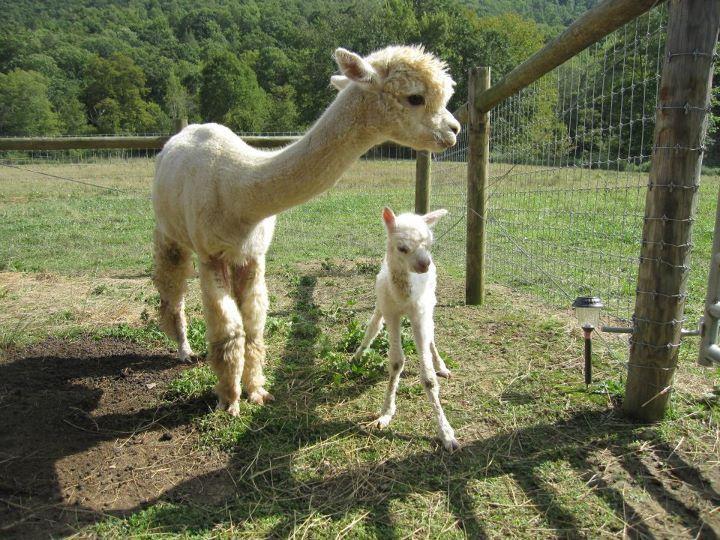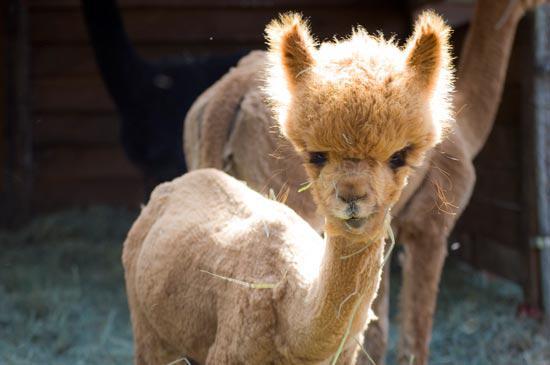The first image is the image on the left, the second image is the image on the right. Given the left and right images, does the statement "Every llama appears to be looking directly at the viewer (i.e. facing the camera)." hold true? Answer yes or no. No. The first image is the image on the left, the second image is the image on the right. Assess this claim about the two images: "There is a young llama in both images.". Correct or not? Answer yes or no. Yes. 